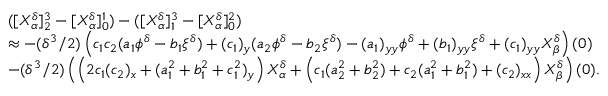Convert formula to latex. <formula><loc_0><loc_0><loc_500><loc_500>\begin{array} { r l } & { ( [ X _ { \alpha } ^ { \delta } ] _ { 2 } ^ { 3 } - [ X _ { \alpha } ^ { \delta } ] _ { 0 } ^ { 1 } ) - ( [ X _ { \alpha } ^ { \delta } ] _ { 1 } ^ { 3 } - [ X _ { \alpha } ^ { \delta } ] _ { 0 } ^ { 2 } ) } \\ & { \approx - ( \delta ^ { 3 } / 2 ) \left ( c _ { 1 } c _ { 2 } ( a _ { 1 } \phi ^ { \delta } - b _ { 1 } \xi ^ { \delta } ) + ( c _ { 1 } ) _ { y } ( a _ { 2 } \phi ^ { \delta } - b _ { 2 } \xi ^ { \delta } ) - ( a _ { 1 } ) _ { y y } \phi ^ { \delta } + ( b _ { 1 } ) _ { y y } \xi ^ { \delta } + ( c _ { 1 } ) _ { y y } X _ { \beta } ^ { \delta } \right ) ( 0 ) } \\ & { - ( \delta ^ { 3 } / 2 ) \left ( \left ( 2 c _ { 1 } ( c _ { 2 } ) _ { x } + ( a _ { 1 } ^ { 2 } + b _ { 1 } ^ { 2 } + c _ { 1 } ^ { 2 } ) _ { y } \right ) X _ { \alpha } ^ { \delta } + \left ( c _ { 1 } ( a _ { 2 } ^ { 2 } + b _ { 2 } ^ { 2 } ) + c _ { 2 } ( a _ { 1 } ^ { 2 } + b _ { 1 } ^ { 2 } ) + ( c _ { 2 } ) _ { x x } \right ) X _ { \beta } ^ { \delta } \right ) ( 0 ) . } \end{array}</formula> 